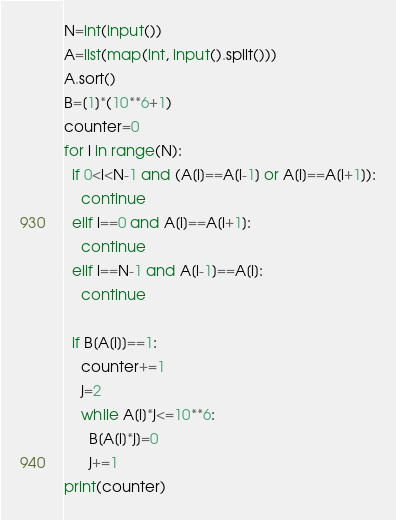Convert code to text. <code><loc_0><loc_0><loc_500><loc_500><_Python_>N=int(input())
A=list(map(int, input().split()))
A.sort()
B=[1]*(10**6+1)
counter=0
for i in range(N):
  if 0<i<N-1 and (A[i]==A[i-1] or A[i]==A[i+1]):
    continue
  elif i==0 and A[i]==A[i+1]:
    continue
  elif i==N-1 and A[i-1]==A[i]:
    continue
  
  if B[A[i]]==1:
    counter+=1
    j=2
    while A[i]*j<=10**6:
      B[A[i]*j]=0
      j+=1
print(counter)</code> 